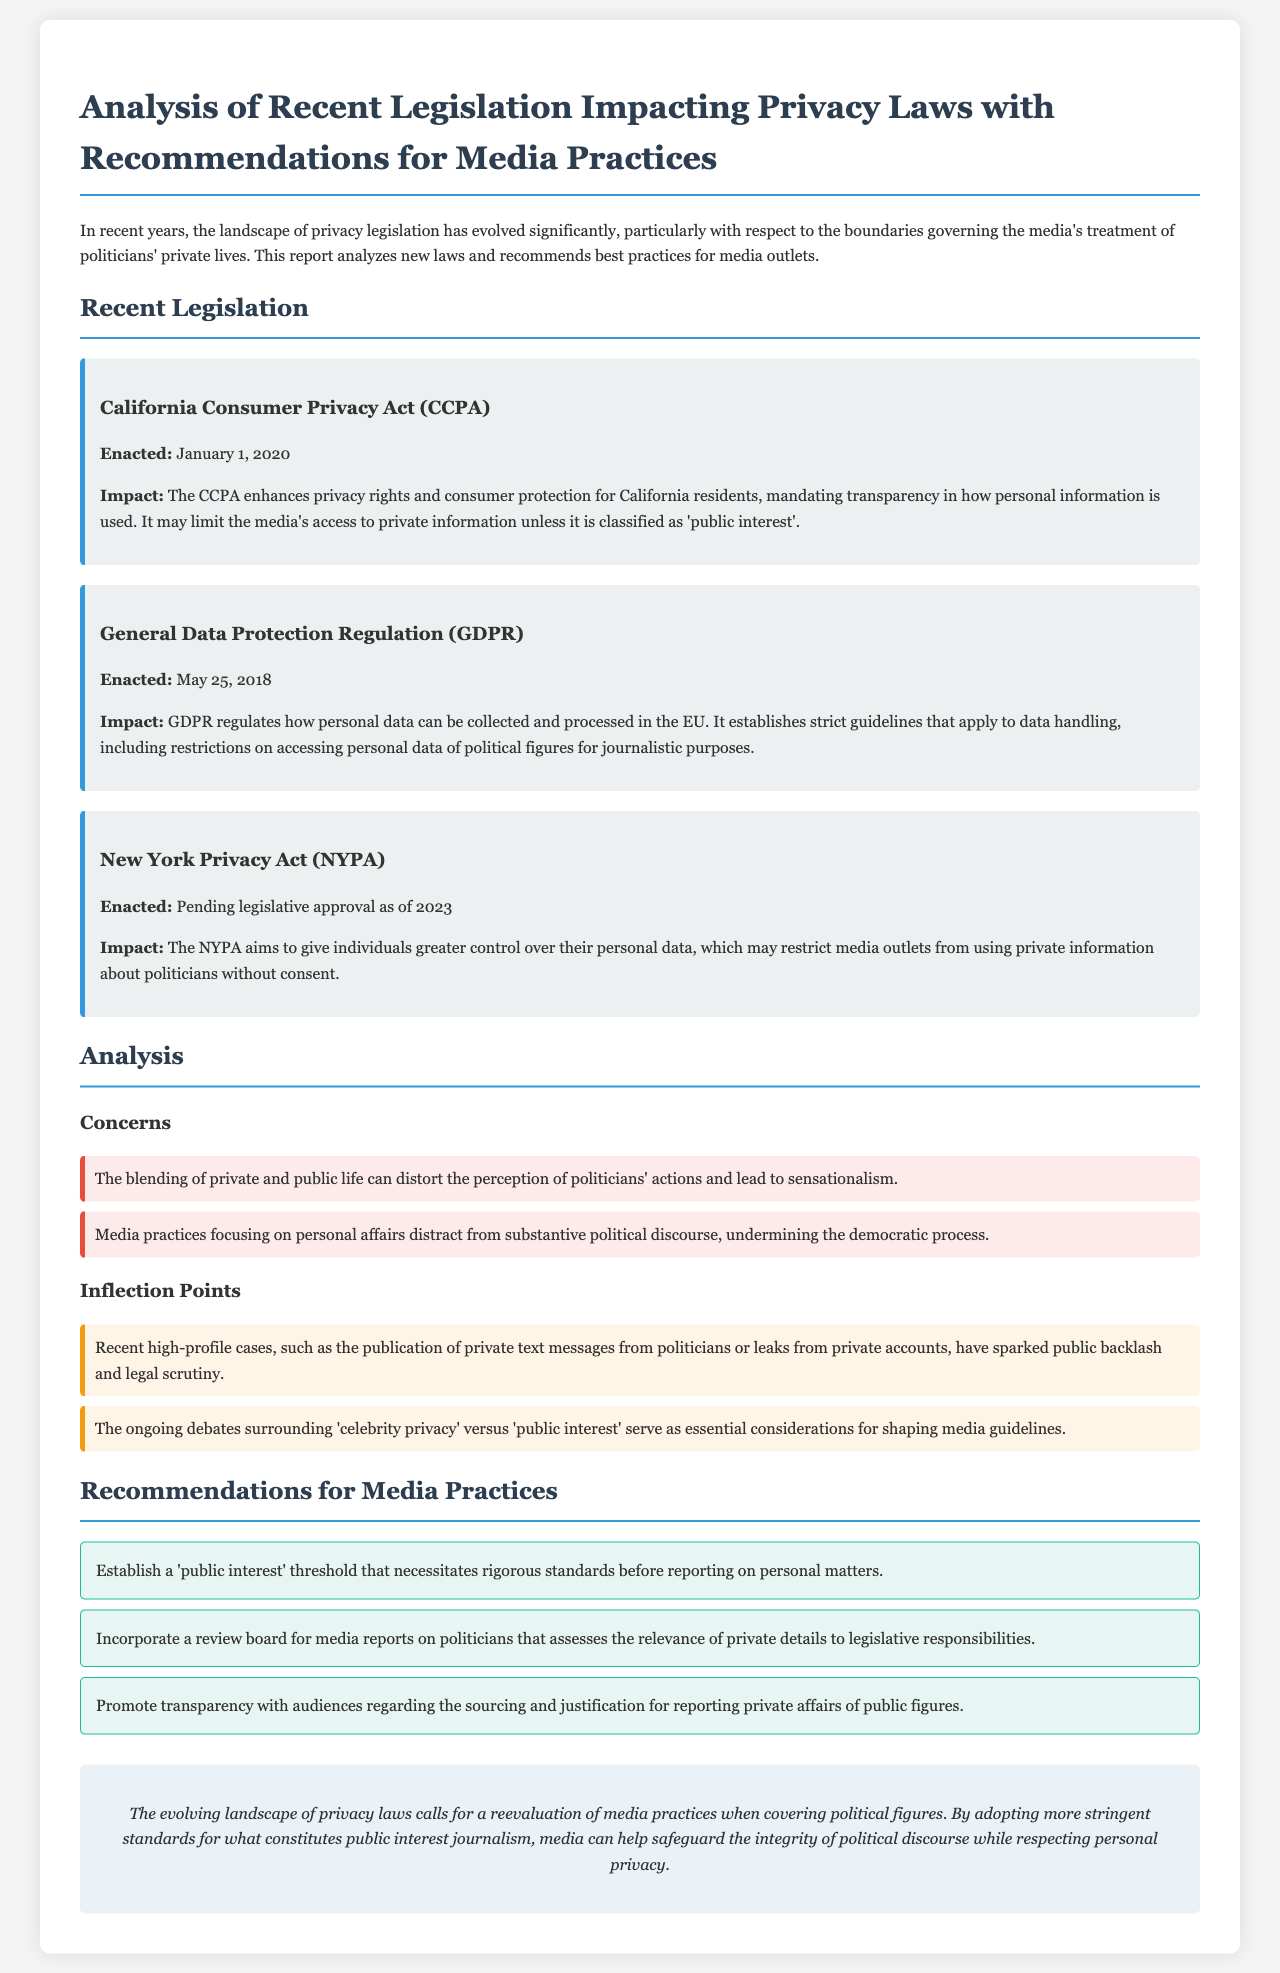What is the title of the report? The title of the report provides a clear indication of its content and purpose which is "Analysis of Recent Legislation Impacting Privacy Laws with Recommendations for Media Practices."
Answer: Analysis of Recent Legislation Impacting Privacy Laws with Recommendations for Media Practices When was the California Consumer Privacy Act enacted? The report explicitly states the enactment date of the California Consumer Privacy Act, which is January 1, 2020.
Answer: January 1, 2020 What is one of the main concerns associated with media practices in political coverage? The document lists concerns associated with media practices, including that focusing on personal affairs distracts from substantive political discourse.
Answer: Distracts from substantive political discourse What is the legislative status of the New York Privacy Act as of 2023? The report indicates that the New York Privacy Act is pending legislative approval as of 2023, informing about its current status.
Answer: Pending legislative approval What does GDPR stand for? The acronym GDPR is mentioned in the report, referring to the General Data Protection Regulation, which is an important piece of legislation.
Answer: General Data Protection Regulation What is one recommendation for media practices mentioned in the report? The report outlines several recommendations for media practices, including establishing a 'public interest' threshold for reporting.
Answer: Establish a 'public interest' threshold What impact does the CCPA have on media access to private information? The report describes the impact of the California Consumer Privacy Act, specifically that it may limit media access to private information unless classified as 'public interest.'
Answer: May limit media's access to private information What is an inflection point mentioned in the document? The document identifies an inflection point regarding high-profile cases that have sparked public backlash and legal scrutiny.
Answer: Publication of private text messages 